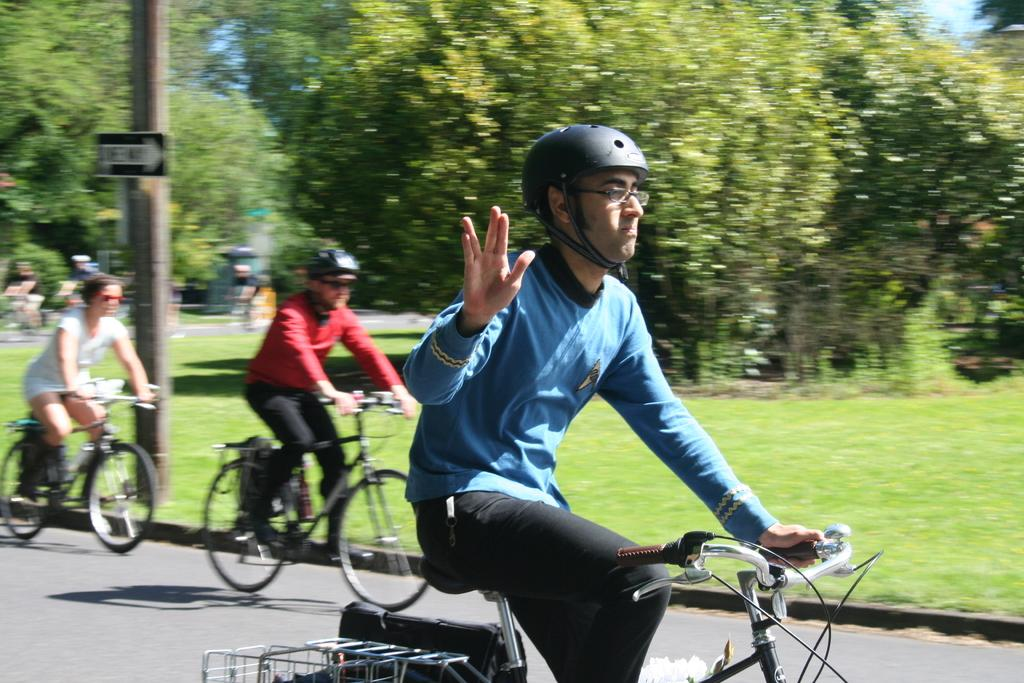What type of vegetation can be seen in the background of the image? There are trees in the background of the image. What part of the sky is visible in the background? A partial part of the sky is visible in the background. What are the persons in the image doing? There are persons riding bicycles on the road. What is the color of the grass in the image? There is fresh green grass in the image. How many fowl are perched on the nail in the image? There are no fowl or nails present in the image. What type of wound can be seen on the person riding a bicycle in the image? There are no wounds visible on the persons riding bicycles in the image. 